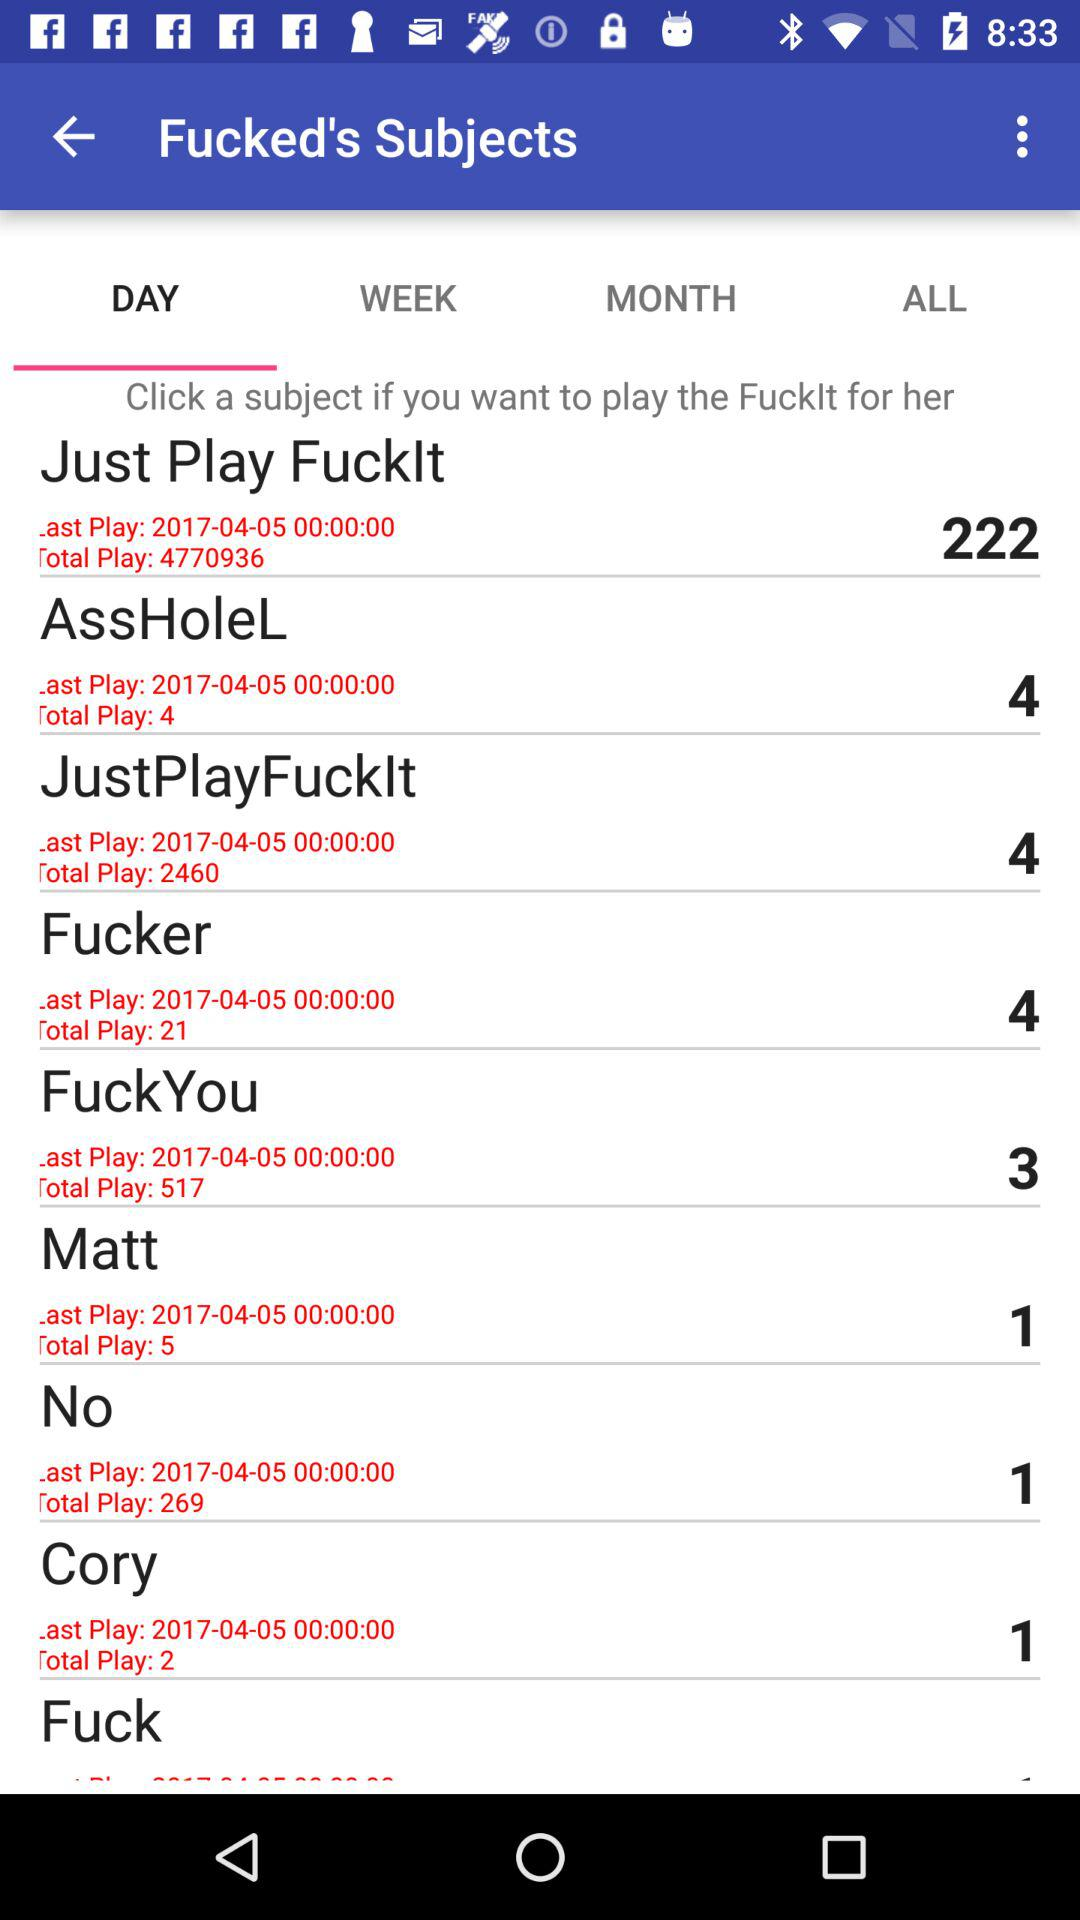What is the last play time of "Just Play FuckIt"? The last play time of "Just Play FuckIt" is 00:00:00. 